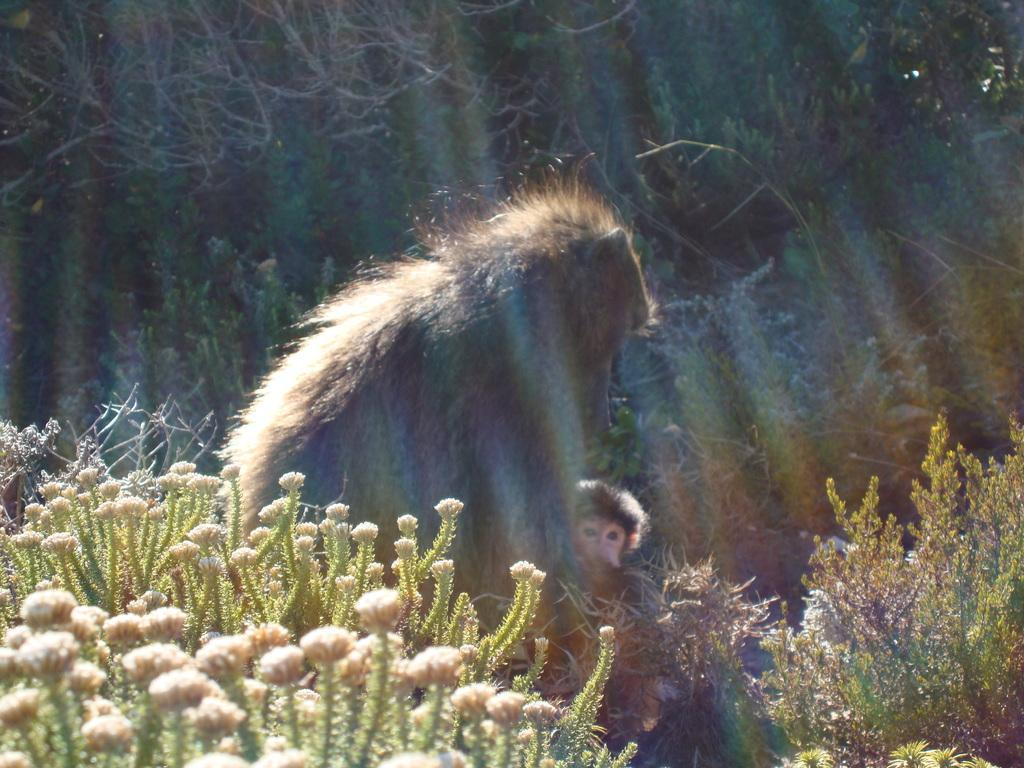What type of animal is in the image? There is a monkey in the image. Can you describe the monkey in the image? There is a baby monkey in the image. What is located on either side of the monkeys? There are plants to the left and right of the monkeys. What can be seen in the background of the image? There are trees in the background of the image. What date is marked on the calendar in the image? There is no calendar present in the image. What type of material is the lead used for in the image? There is no lead present in the image. 